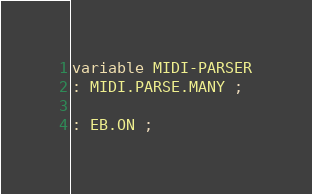<code> <loc_0><loc_0><loc_500><loc_500><_Forth_>variable MIDI-PARSER
: MIDI.PARSE.MANY ;

: EB.ON ;
</code> 